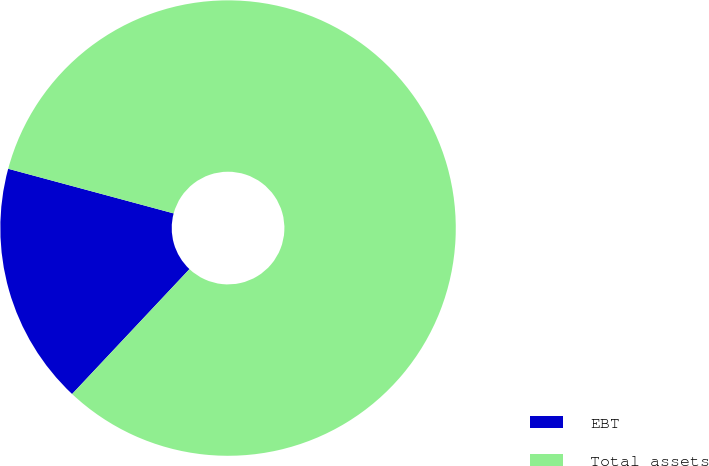<chart> <loc_0><loc_0><loc_500><loc_500><pie_chart><fcel>EBT<fcel>Total assets<nl><fcel>17.19%<fcel>82.81%<nl></chart> 